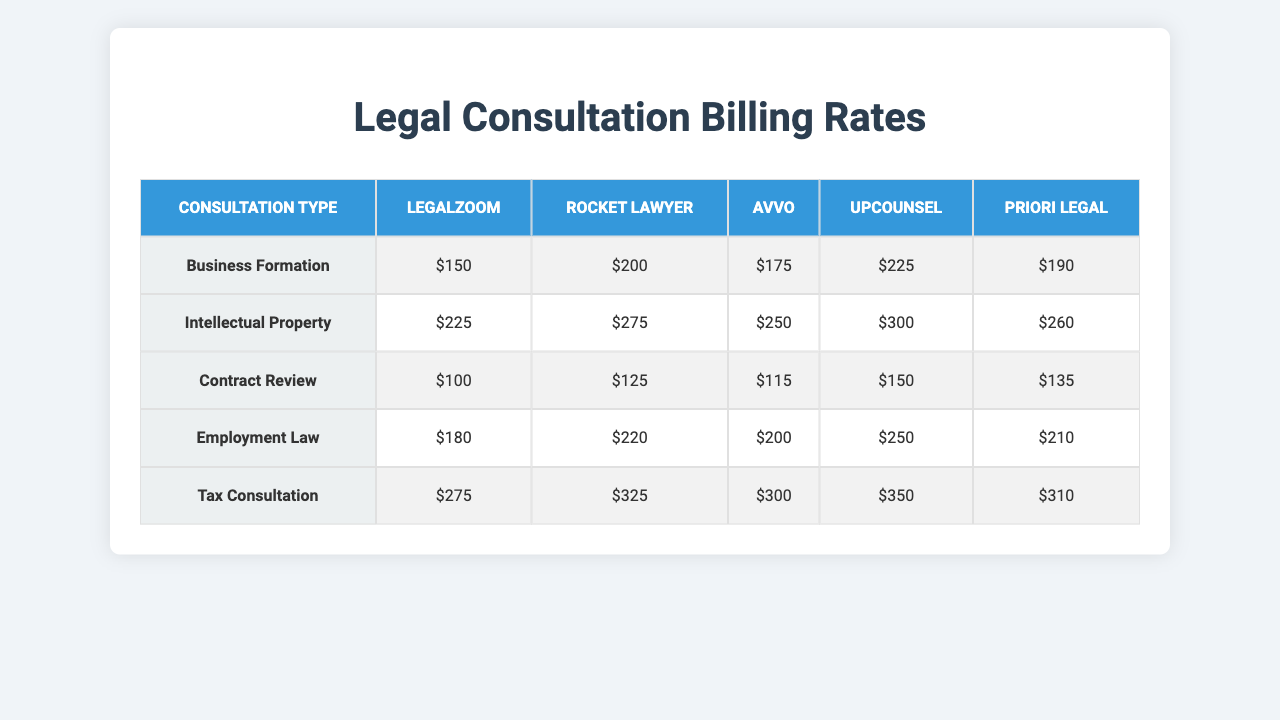What is the billing rate for Business Formation on LegalZoom? The table shows that the billing rate for Business Formation on LegalZoom is $150.
Answer: $150 Which platform has the highest billing rate for Contract Review? Looking at the Contract Review row, Priori Legal has the highest billing rate at $300.
Answer: $300 What is the average billing rate for Tax Consultation across all platforms? To calculate the average, we sum the billing rates: 190 + 260 + 135 + 210 + 310 = 1105, then divide by 5 to get 1105/5 = 221.
Answer: $221 Is the billing rate for Employment Law the same on LegalZoom and UpCounsel? Looking at the table, LegalZoom charges $225 and UpCounsel charges $250, so they are not the same.
Answer: No What is the difference in billing rates for Intellectual Property between Priori Legal and Avvo? The billing rate for Intellectual Property is $325 for Priori Legal and $115 for Avvo. The difference is 325 - 115 = 210.
Answer: $210 Which platform offers the lowest billing rate for Business Formation? The minimum value in the Business Formation row is $150 (LegalZoom), which is lower than the other platforms.
Answer: LegalZoom What is the highest billing rate for any consultation type on UpCounsel? By checking UpCounsel's rates, the highest billing rate is $250 for Employment Law.
Answer: $250 If you were to add the billing rates of Contract Review from both Rocket Lawyer and Avvo, what would be the total? Rocket Lawyer charges $250 and Avvo charges $115 for Contract Review. Adding them gives 250 + 115 = 365.
Answer: $365 Which type of consultation has the highest overall billing rate on Priori Legal? The billing rates for Priori Legal are: 275 (Business Formation), 325 (Intellectual Property), 300 (Contract Review), 350 (Employment Law), and 310 (Tax Consultation). The highest is 350 for Employment Law.
Answer: Employment Law Is it true that Avvo has the lowest billing rate for Tax Consultation? Avvo's billing rate for Tax Consultation is $135, and it's higher than LegalZoom's $190, so this statement is false.
Answer: No 